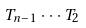Convert formula to latex. <formula><loc_0><loc_0><loc_500><loc_500>T _ { n - 1 } \cdot \cdot \cdot T _ { 2 }</formula> 